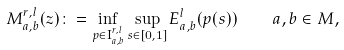Convert formula to latex. <formula><loc_0><loc_0><loc_500><loc_500>M _ { a , b } ^ { r , l } ( z ) \colon = \inf _ { p \in \mathbf I _ { a , b } ^ { r , l } } \sup _ { s \in [ 0 , 1 ] } E _ { a , b } ^ { l } ( p ( s ) ) \quad a , b \in M ,</formula> 